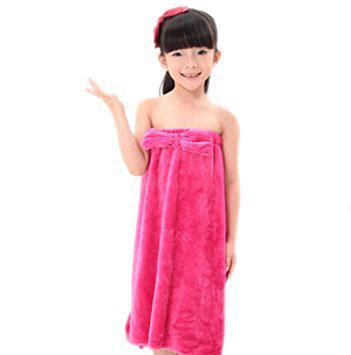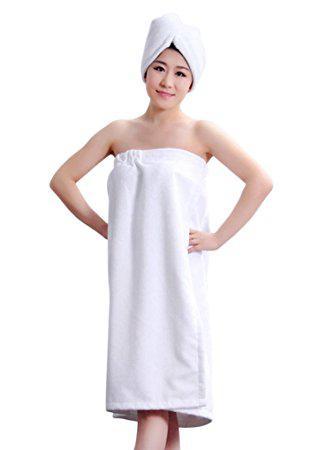The first image is the image on the left, the second image is the image on the right. Examine the images to the left and right. Is the description "One woman's towel is pink with white polka dots." accurate? Answer yes or no. No. The first image is the image on the left, the second image is the image on the right. Analyze the images presented: Is the assertion "At least one of the women has her hand to her face." valid? Answer yes or no. No. 